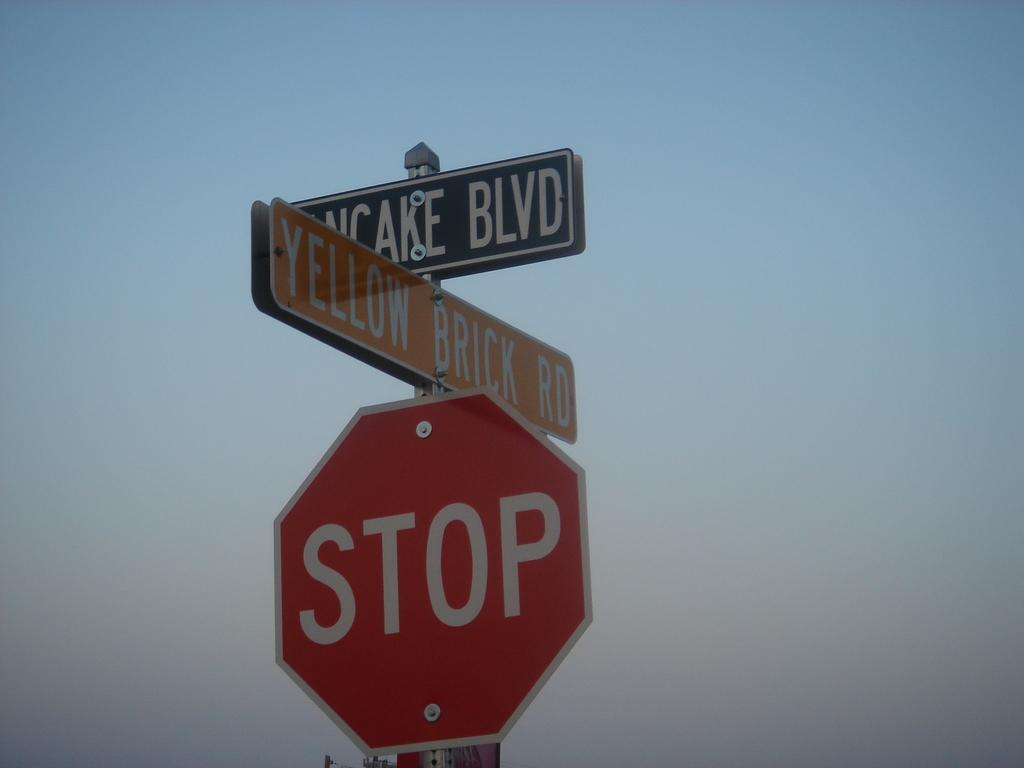What objects are present in the image? There are boards in the image. What is written on the boards? The boards have text written on them. Where are the boards located in the image? The boards are in the front of the image. How many bats are hanging from the boards in the image? There are no bats present in the image; it only features boards with text. 